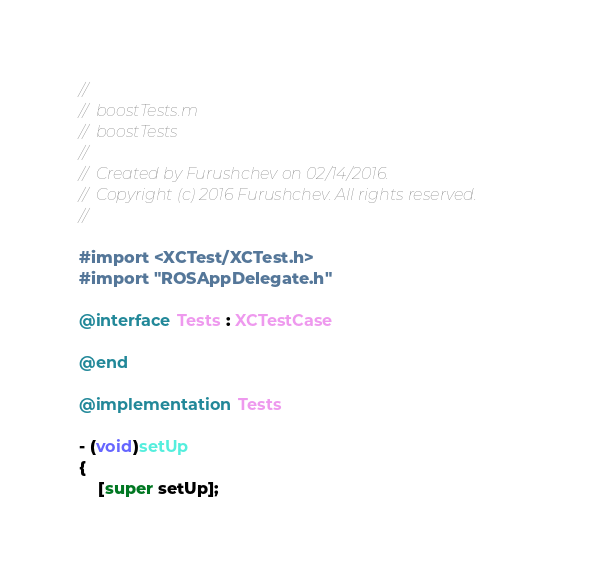<code> <loc_0><loc_0><loc_500><loc_500><_ObjectiveC_>//
//  boostTests.m
//  boostTests
//
//  Created by Furushchev on 02/14/2016.
//  Copyright (c) 2016 Furushchev. All rights reserved.
//

#import <XCTest/XCTest.h>
#import "ROSAppDelegate.h"

@interface Tests : XCTestCase

@end

@implementation Tests

- (void)setUp
{
    [super setUp];</code> 